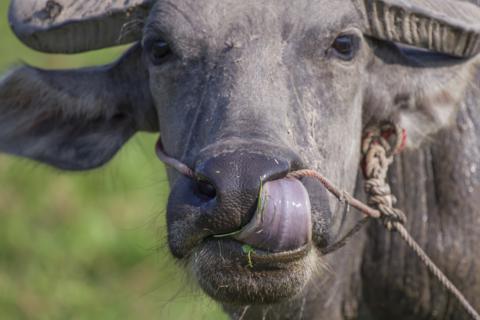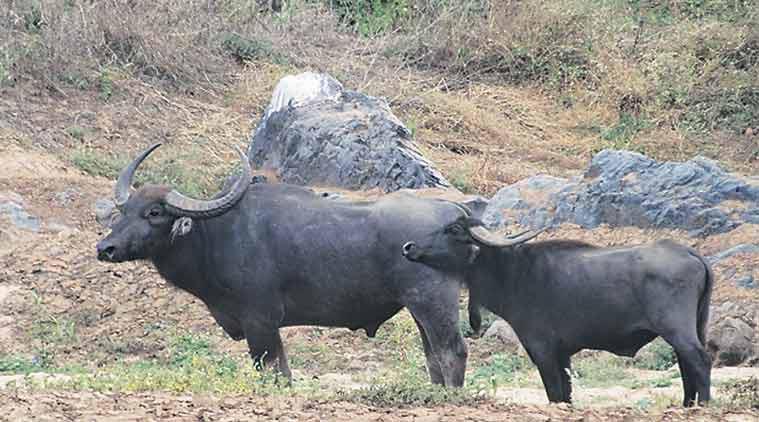The first image is the image on the left, the second image is the image on the right. For the images shown, is this caption "One image shows exactly two water buffalo, both in profile." true? Answer yes or no. Yes. 